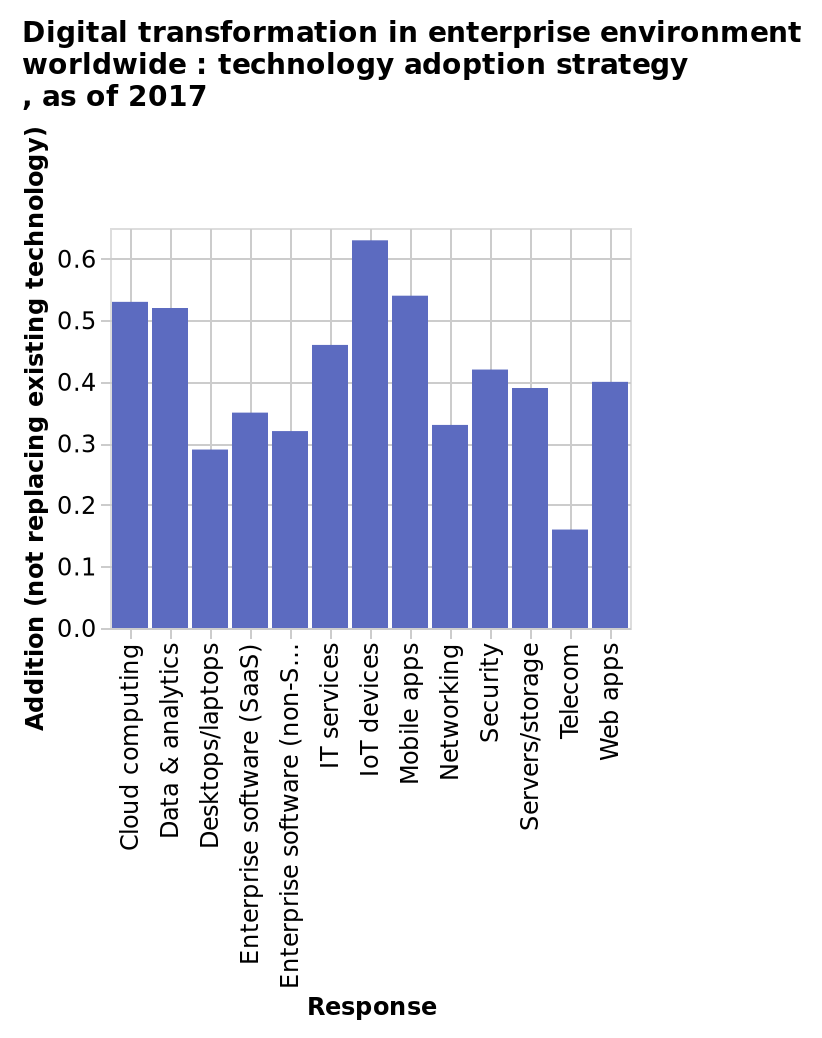<image>
please summary the statistics and relations of the chart IOT devices has been the largest example of digital transformation. Was there any trend in device popularity? No, there was no trend in device popularity. please enumerates aspects of the construction of the chart This is a bar chart named Digital transformation in enterprise environment worldwide : technology adoption strategy , as of 2017. The x-axis plots Response as categorical scale starting with Cloud computing and ending with Web apps while the y-axis plots Addition (not replacing existing technology) along scale of range 0.0 to 0.6. 